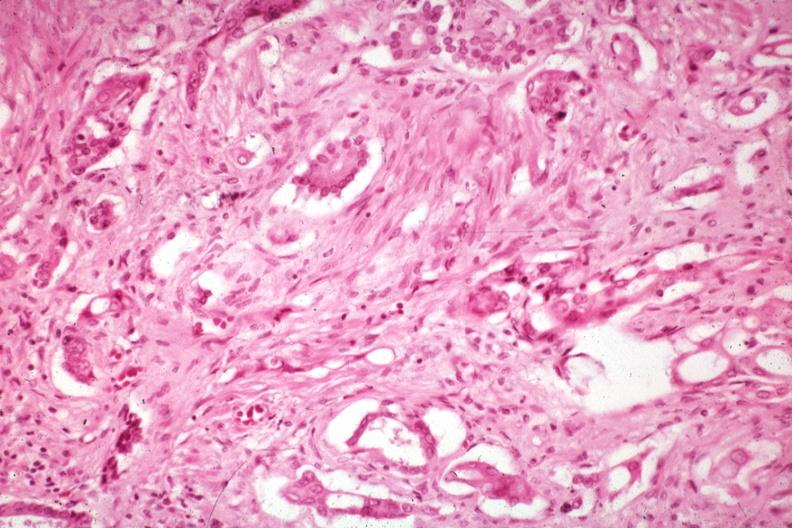s pancreas present?
Answer the question using a single word or phrase. Yes 